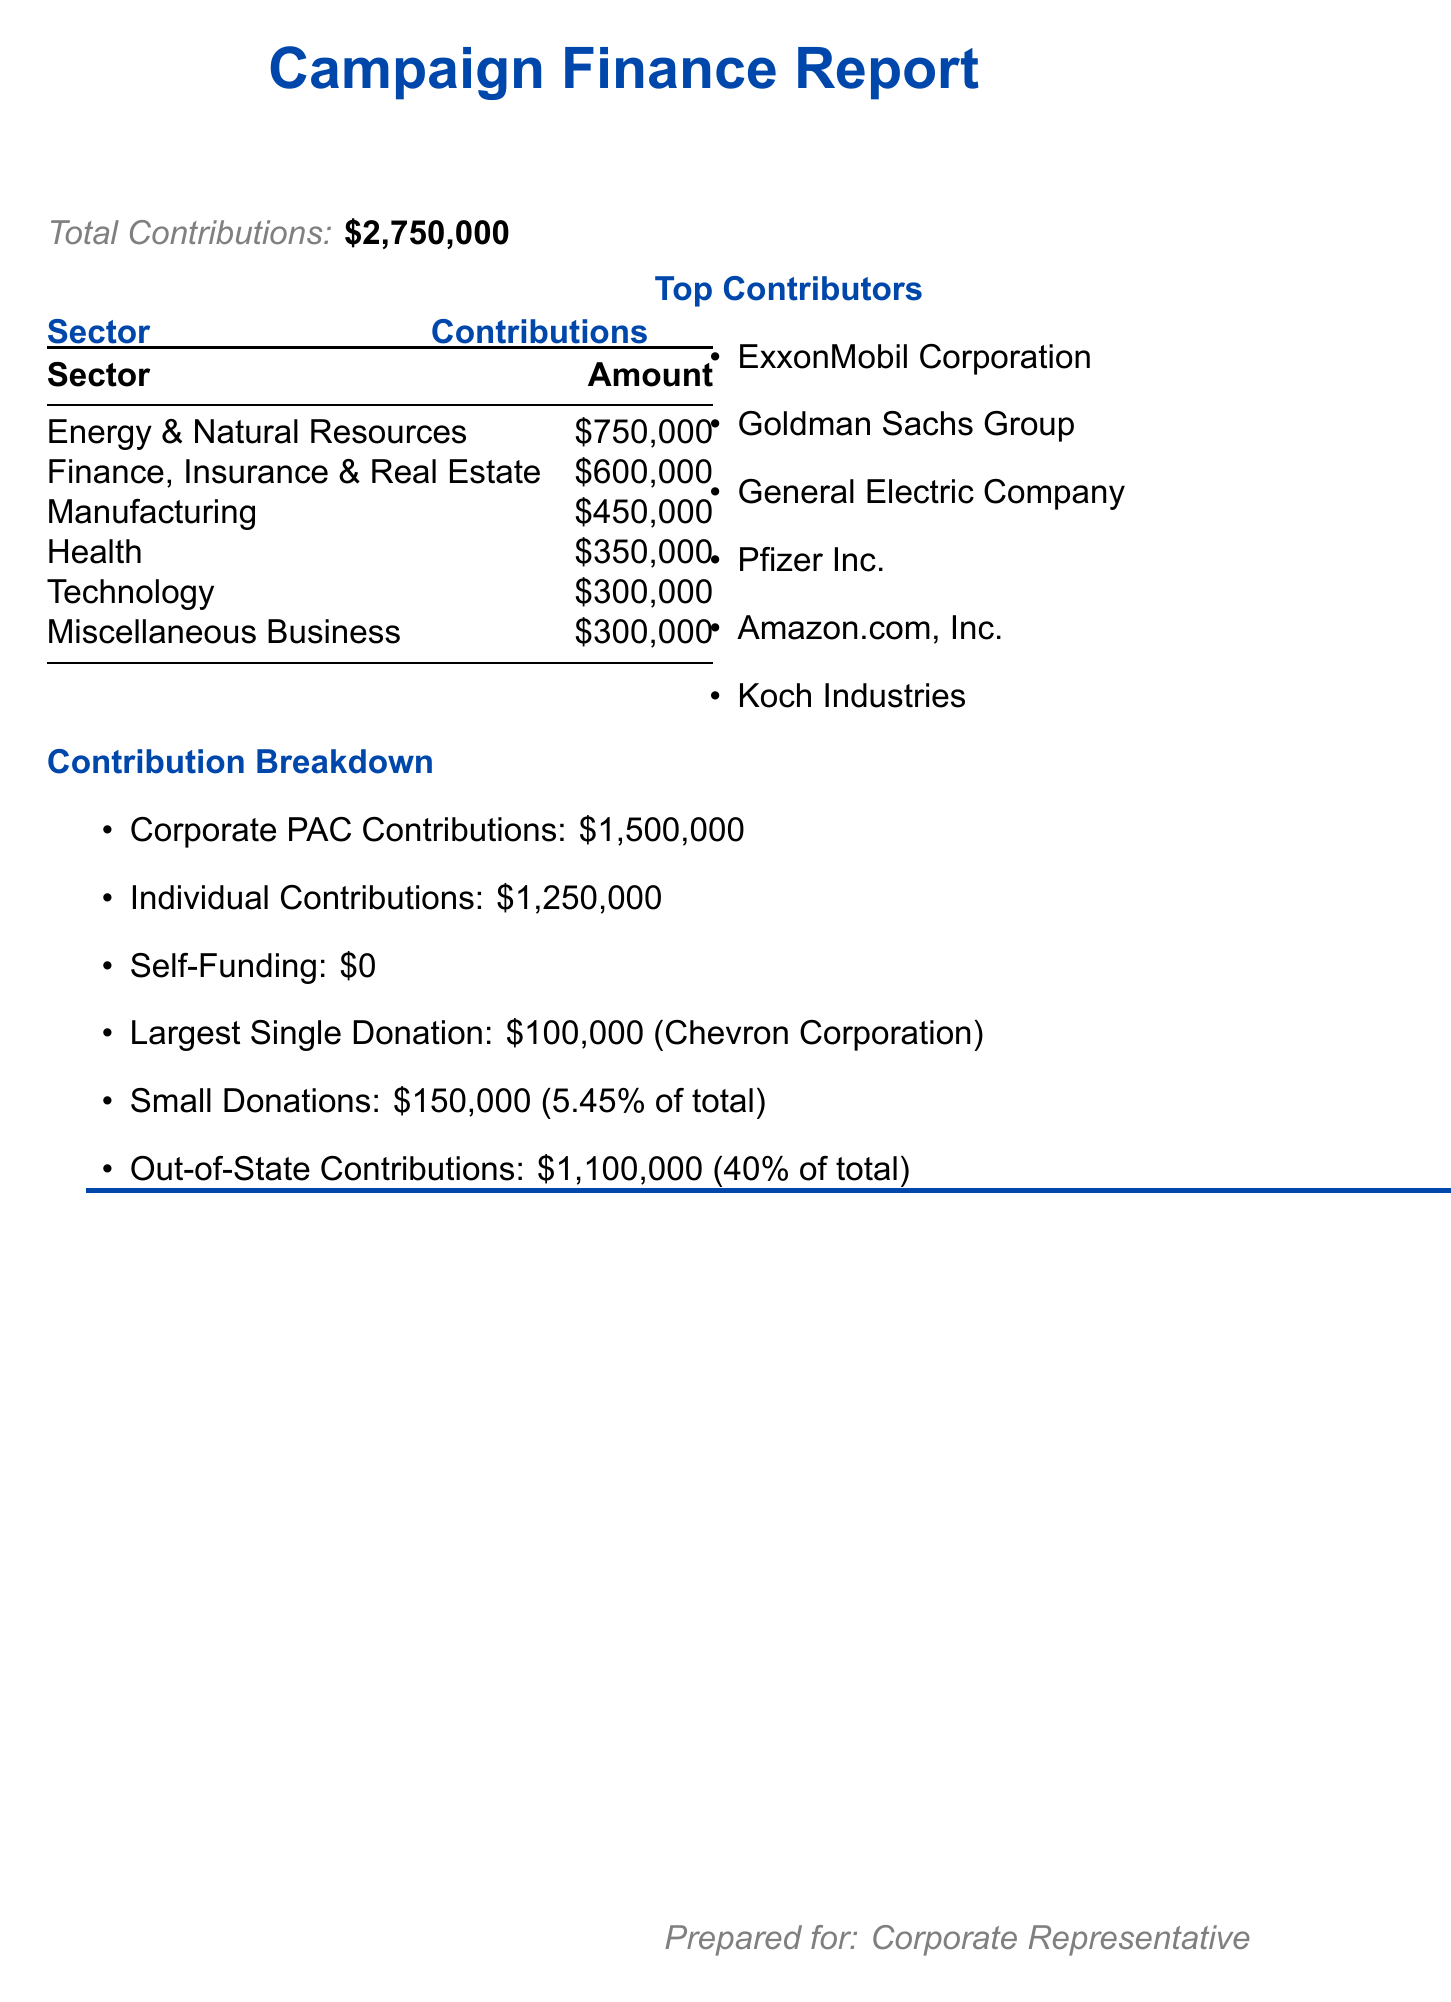What is the total amount of campaign contributions? The total amount of campaign contributions is clearly stated in the document as $2,750,000.
Answer: $2,750,000 Which sector received the highest contributions? The sector with the highest contributions is highlighted in the document, which is Energy & Natural Resources with $750,000.
Answer: Energy & Natural Resources Who is the top contributor from the Finance, Insurance & Real Estate sector? The document specifies the top contributor in this sector as Goldman Sachs Group.
Answer: Goldman Sachs Group What percentage of total contributions came from small donations? The percentage of total contributions that came from small donations is explicitly stated as 5.45%.
Answer: 5.45% How much was contributed from out-of-state sources? The document details the contributions from out-of-state sources as $1,100,000.
Answer: $1,100,000 What is the largest single donation amount? The document mentions the largest single donation is $100,000 from Chevron Corporation.
Answer: $100,000 How much did corporate PACs contribute? Contributions from corporate PACs are summarized in the document as $1,500,000.
Answer: $1,500,000 What is the total amount from individual contributions? The document reports that individual contributions total $1,250,000.
Answer: $1,250,000 Which company is the top contributor in the Technology sector? The top contributor in the Technology sector is stated as Amazon.com, Inc. in the document.
Answer: Amazon.com, Inc 